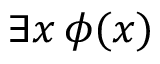Convert formula to latex. <formula><loc_0><loc_0><loc_500><loc_500>\exists x \, \phi ( x )</formula> 